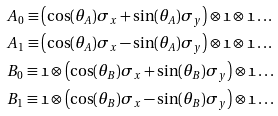Convert formula to latex. <formula><loc_0><loc_0><loc_500><loc_500>& A _ { 0 } \equiv \left ( \cos ( \theta _ { A } ) \sigma _ { x } + \sin ( \theta _ { A } ) \sigma _ { y } \right ) \otimes \mathfrak { 1 } \otimes \mathfrak { 1 } \dots \\ & A _ { 1 } \equiv \left ( \cos ( \theta _ { A } ) \sigma _ { x } - \sin ( \theta _ { A } ) \sigma _ { y } \right ) \otimes \mathfrak { 1 } \otimes \mathfrak { 1 } \dots \\ & B _ { 0 } \equiv \mathfrak { 1 } \otimes \left ( \cos ( \theta _ { B } ) \sigma _ { x } + \sin ( \theta _ { B } ) \sigma _ { y } \right ) \otimes \mathfrak { 1 } \dots \\ & B _ { 1 } \equiv \mathfrak { 1 } \otimes \left ( \cos ( \theta _ { B } ) \sigma _ { x } - \sin ( \theta _ { B } ) \sigma _ { y } \right ) \otimes \mathfrak { 1 } \dots</formula> 